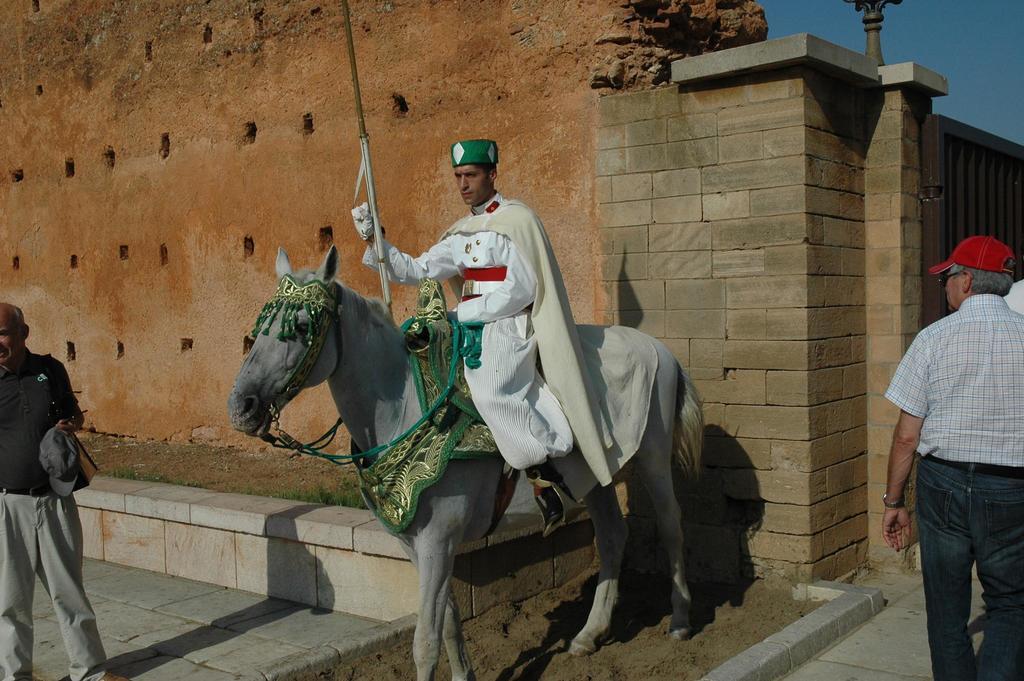Please provide a concise description of this image. There is a man sitting on the horse. This is floor. Here we can see two persons. On the background there is a wall and this is sky. 